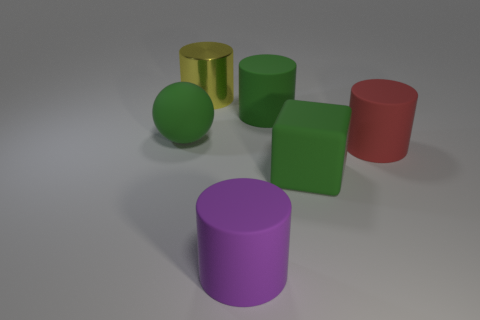Subtract 1 cylinders. How many cylinders are left? 3 Subtract all red cylinders. Subtract all yellow balls. How many cylinders are left? 3 Add 3 large red cylinders. How many objects exist? 9 Subtract all balls. How many objects are left? 5 Subtract all large gray things. Subtract all rubber cubes. How many objects are left? 5 Add 6 big red rubber cylinders. How many big red rubber cylinders are left? 7 Add 3 big metal things. How many big metal things exist? 4 Subtract 0 red spheres. How many objects are left? 6 